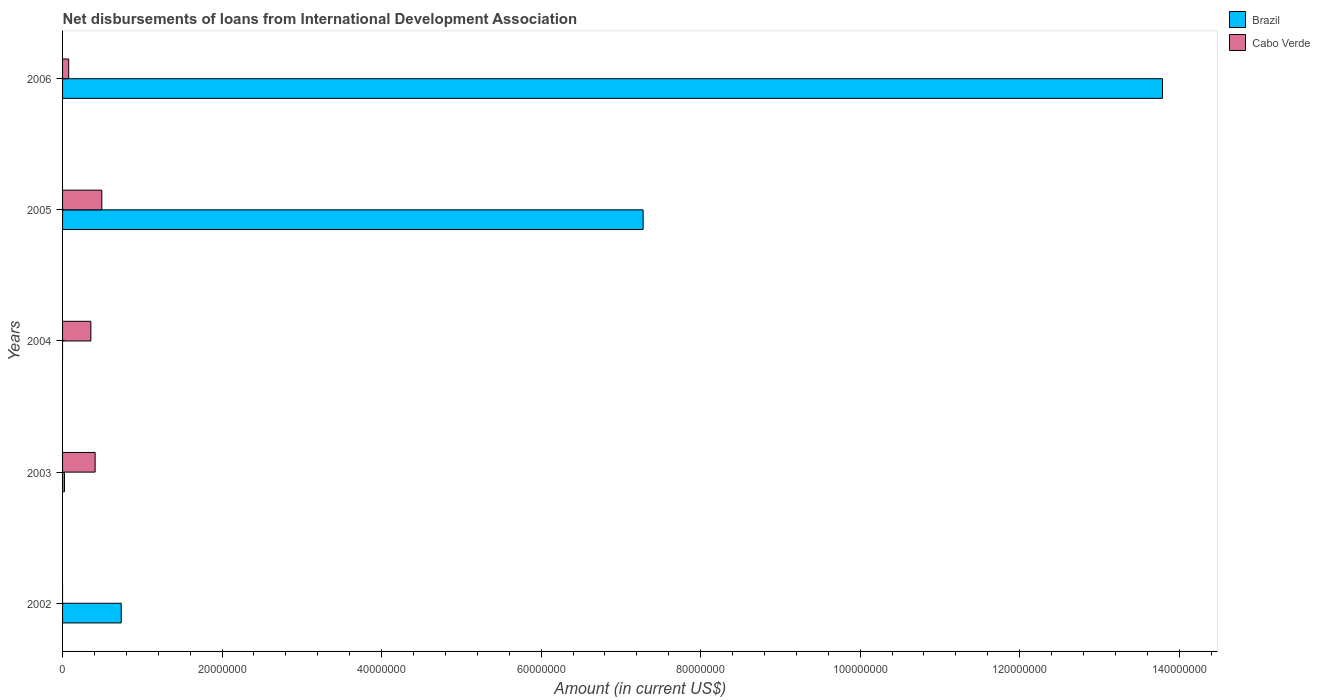Are the number of bars per tick equal to the number of legend labels?
Your answer should be compact. No. How many bars are there on the 4th tick from the top?
Ensure brevity in your answer.  2. How many bars are there on the 5th tick from the bottom?
Give a very brief answer. 2. In how many cases, is the number of bars for a given year not equal to the number of legend labels?
Give a very brief answer. 2. Across all years, what is the maximum amount of loans disbursed in Cabo Verde?
Your answer should be compact. 4.92e+06. Across all years, what is the minimum amount of loans disbursed in Brazil?
Keep it short and to the point. 0. In which year was the amount of loans disbursed in Cabo Verde maximum?
Offer a very short reply. 2005. What is the total amount of loans disbursed in Cabo Verde in the graph?
Make the answer very short. 1.33e+07. What is the difference between the amount of loans disbursed in Brazil in 2003 and that in 2005?
Your answer should be very brief. -7.26e+07. What is the difference between the amount of loans disbursed in Brazil in 2006 and the amount of loans disbursed in Cabo Verde in 2005?
Offer a very short reply. 1.33e+08. What is the average amount of loans disbursed in Brazil per year?
Provide a succinct answer. 4.37e+07. In the year 2005, what is the difference between the amount of loans disbursed in Cabo Verde and amount of loans disbursed in Brazil?
Your response must be concise. -6.79e+07. What is the ratio of the amount of loans disbursed in Cabo Verde in 2003 to that in 2004?
Offer a very short reply. 1.15. Is the amount of loans disbursed in Cabo Verde in 2005 less than that in 2006?
Ensure brevity in your answer.  No. What is the difference between the highest and the second highest amount of loans disbursed in Brazil?
Offer a terse response. 6.51e+07. What is the difference between the highest and the lowest amount of loans disbursed in Cabo Verde?
Provide a short and direct response. 4.92e+06. How many bars are there?
Your answer should be compact. 8. What is the difference between two consecutive major ticks on the X-axis?
Your answer should be compact. 2.00e+07. Are the values on the major ticks of X-axis written in scientific E-notation?
Your response must be concise. No. Where does the legend appear in the graph?
Provide a succinct answer. Top right. How are the legend labels stacked?
Ensure brevity in your answer.  Vertical. What is the title of the graph?
Give a very brief answer. Net disbursements of loans from International Development Association. What is the label or title of the X-axis?
Keep it short and to the point. Amount (in current US$). What is the label or title of the Y-axis?
Provide a succinct answer. Years. What is the Amount (in current US$) of Brazil in 2002?
Your answer should be very brief. 7.36e+06. What is the Amount (in current US$) in Brazil in 2003?
Your answer should be very brief. 2.38e+05. What is the Amount (in current US$) in Cabo Verde in 2003?
Provide a short and direct response. 4.08e+06. What is the Amount (in current US$) of Cabo Verde in 2004?
Your answer should be very brief. 3.55e+06. What is the Amount (in current US$) in Brazil in 2005?
Ensure brevity in your answer.  7.28e+07. What is the Amount (in current US$) in Cabo Verde in 2005?
Your answer should be very brief. 4.92e+06. What is the Amount (in current US$) of Brazil in 2006?
Make the answer very short. 1.38e+08. What is the Amount (in current US$) of Cabo Verde in 2006?
Make the answer very short. 7.69e+05. Across all years, what is the maximum Amount (in current US$) of Brazil?
Make the answer very short. 1.38e+08. Across all years, what is the maximum Amount (in current US$) of Cabo Verde?
Keep it short and to the point. 4.92e+06. What is the total Amount (in current US$) of Brazil in the graph?
Provide a short and direct response. 2.18e+08. What is the total Amount (in current US$) in Cabo Verde in the graph?
Offer a very short reply. 1.33e+07. What is the difference between the Amount (in current US$) in Brazil in 2002 and that in 2003?
Make the answer very short. 7.12e+06. What is the difference between the Amount (in current US$) in Brazil in 2002 and that in 2005?
Provide a short and direct response. -6.54e+07. What is the difference between the Amount (in current US$) in Brazil in 2002 and that in 2006?
Offer a terse response. -1.31e+08. What is the difference between the Amount (in current US$) in Cabo Verde in 2003 and that in 2004?
Make the answer very short. 5.37e+05. What is the difference between the Amount (in current US$) of Brazil in 2003 and that in 2005?
Give a very brief answer. -7.26e+07. What is the difference between the Amount (in current US$) of Cabo Verde in 2003 and that in 2005?
Offer a terse response. -8.38e+05. What is the difference between the Amount (in current US$) of Brazil in 2003 and that in 2006?
Offer a very short reply. -1.38e+08. What is the difference between the Amount (in current US$) of Cabo Verde in 2003 and that in 2006?
Give a very brief answer. 3.32e+06. What is the difference between the Amount (in current US$) in Cabo Verde in 2004 and that in 2005?
Offer a terse response. -1.38e+06. What is the difference between the Amount (in current US$) in Cabo Verde in 2004 and that in 2006?
Your answer should be very brief. 2.78e+06. What is the difference between the Amount (in current US$) in Brazil in 2005 and that in 2006?
Provide a short and direct response. -6.51e+07. What is the difference between the Amount (in current US$) in Cabo Verde in 2005 and that in 2006?
Provide a short and direct response. 4.15e+06. What is the difference between the Amount (in current US$) in Brazil in 2002 and the Amount (in current US$) in Cabo Verde in 2003?
Keep it short and to the point. 3.27e+06. What is the difference between the Amount (in current US$) of Brazil in 2002 and the Amount (in current US$) of Cabo Verde in 2004?
Ensure brevity in your answer.  3.81e+06. What is the difference between the Amount (in current US$) in Brazil in 2002 and the Amount (in current US$) in Cabo Verde in 2005?
Ensure brevity in your answer.  2.43e+06. What is the difference between the Amount (in current US$) in Brazil in 2002 and the Amount (in current US$) in Cabo Verde in 2006?
Ensure brevity in your answer.  6.59e+06. What is the difference between the Amount (in current US$) of Brazil in 2003 and the Amount (in current US$) of Cabo Verde in 2004?
Provide a succinct answer. -3.31e+06. What is the difference between the Amount (in current US$) in Brazil in 2003 and the Amount (in current US$) in Cabo Verde in 2005?
Provide a short and direct response. -4.68e+06. What is the difference between the Amount (in current US$) of Brazil in 2003 and the Amount (in current US$) of Cabo Verde in 2006?
Give a very brief answer. -5.31e+05. What is the difference between the Amount (in current US$) in Brazil in 2005 and the Amount (in current US$) in Cabo Verde in 2006?
Ensure brevity in your answer.  7.20e+07. What is the average Amount (in current US$) of Brazil per year?
Your answer should be very brief. 4.37e+07. What is the average Amount (in current US$) in Cabo Verde per year?
Keep it short and to the point. 2.66e+06. In the year 2003, what is the difference between the Amount (in current US$) in Brazil and Amount (in current US$) in Cabo Verde?
Offer a terse response. -3.85e+06. In the year 2005, what is the difference between the Amount (in current US$) in Brazil and Amount (in current US$) in Cabo Verde?
Offer a terse response. 6.79e+07. In the year 2006, what is the difference between the Amount (in current US$) in Brazil and Amount (in current US$) in Cabo Verde?
Provide a short and direct response. 1.37e+08. What is the ratio of the Amount (in current US$) of Brazil in 2002 to that in 2003?
Your response must be concise. 30.91. What is the ratio of the Amount (in current US$) in Brazil in 2002 to that in 2005?
Offer a very short reply. 0.1. What is the ratio of the Amount (in current US$) in Brazil in 2002 to that in 2006?
Provide a short and direct response. 0.05. What is the ratio of the Amount (in current US$) of Cabo Verde in 2003 to that in 2004?
Your answer should be very brief. 1.15. What is the ratio of the Amount (in current US$) of Brazil in 2003 to that in 2005?
Your answer should be compact. 0. What is the ratio of the Amount (in current US$) of Cabo Verde in 2003 to that in 2005?
Offer a very short reply. 0.83. What is the ratio of the Amount (in current US$) in Brazil in 2003 to that in 2006?
Give a very brief answer. 0. What is the ratio of the Amount (in current US$) of Cabo Verde in 2003 to that in 2006?
Offer a very short reply. 5.31. What is the ratio of the Amount (in current US$) in Cabo Verde in 2004 to that in 2005?
Your answer should be very brief. 0.72. What is the ratio of the Amount (in current US$) in Cabo Verde in 2004 to that in 2006?
Your answer should be very brief. 4.61. What is the ratio of the Amount (in current US$) in Brazil in 2005 to that in 2006?
Offer a terse response. 0.53. What is the ratio of the Amount (in current US$) in Cabo Verde in 2005 to that in 2006?
Your answer should be compact. 6.4. What is the difference between the highest and the second highest Amount (in current US$) in Brazil?
Keep it short and to the point. 6.51e+07. What is the difference between the highest and the second highest Amount (in current US$) of Cabo Verde?
Provide a short and direct response. 8.38e+05. What is the difference between the highest and the lowest Amount (in current US$) in Brazil?
Provide a succinct answer. 1.38e+08. What is the difference between the highest and the lowest Amount (in current US$) of Cabo Verde?
Offer a very short reply. 4.92e+06. 